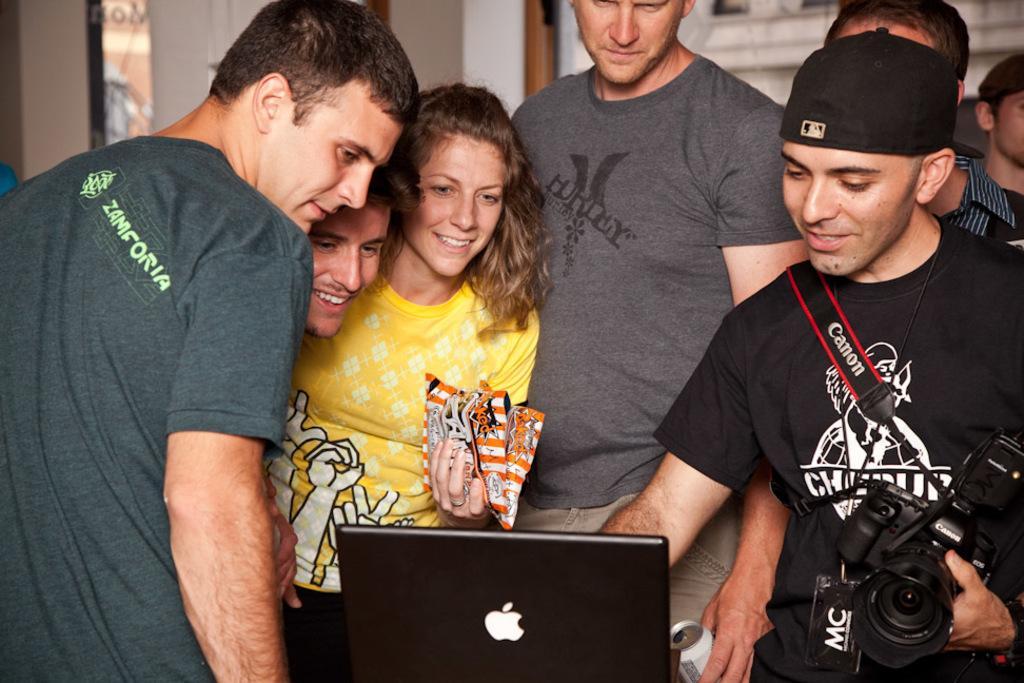Please provide a concise description of this image. Here we see some persons. He is holding a camera with his hand and they are smiling. This is a laptop. 